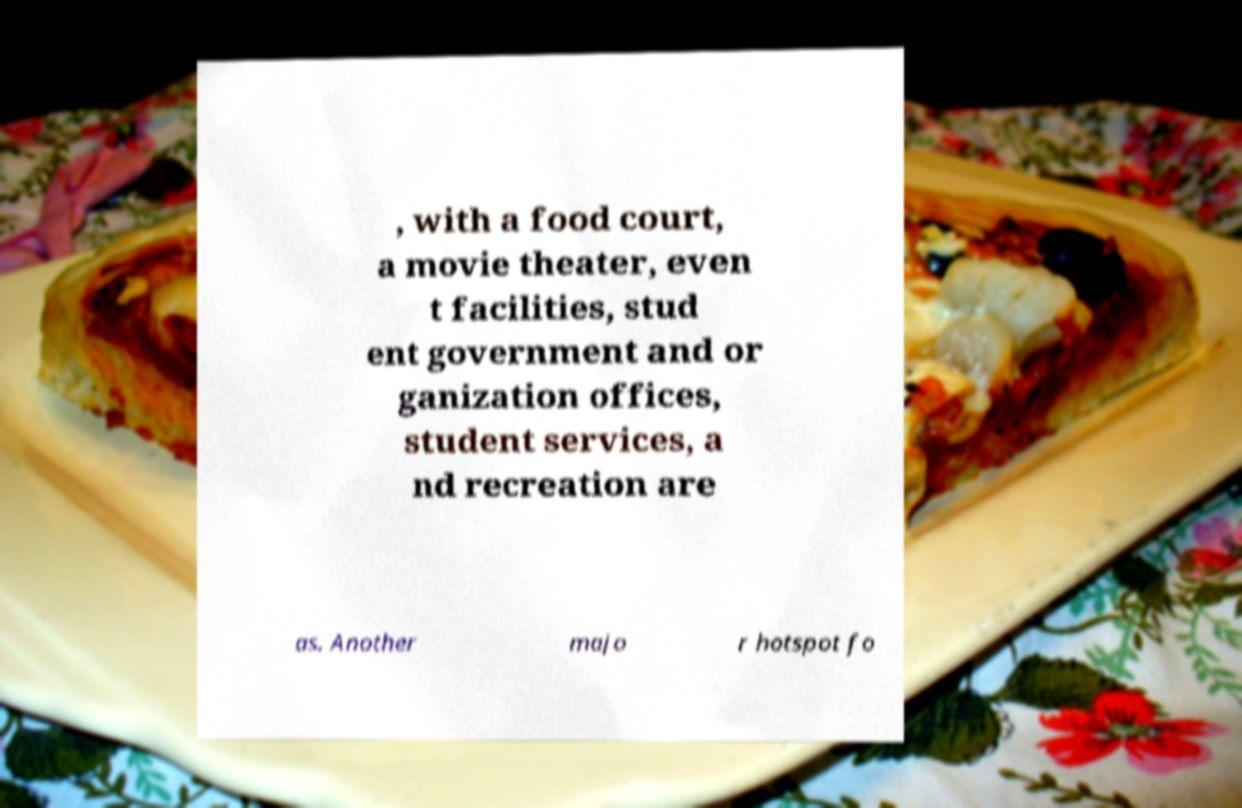For documentation purposes, I need the text within this image transcribed. Could you provide that? , with a food court, a movie theater, even t facilities, stud ent government and or ganization offices, student services, a nd recreation are as. Another majo r hotspot fo 